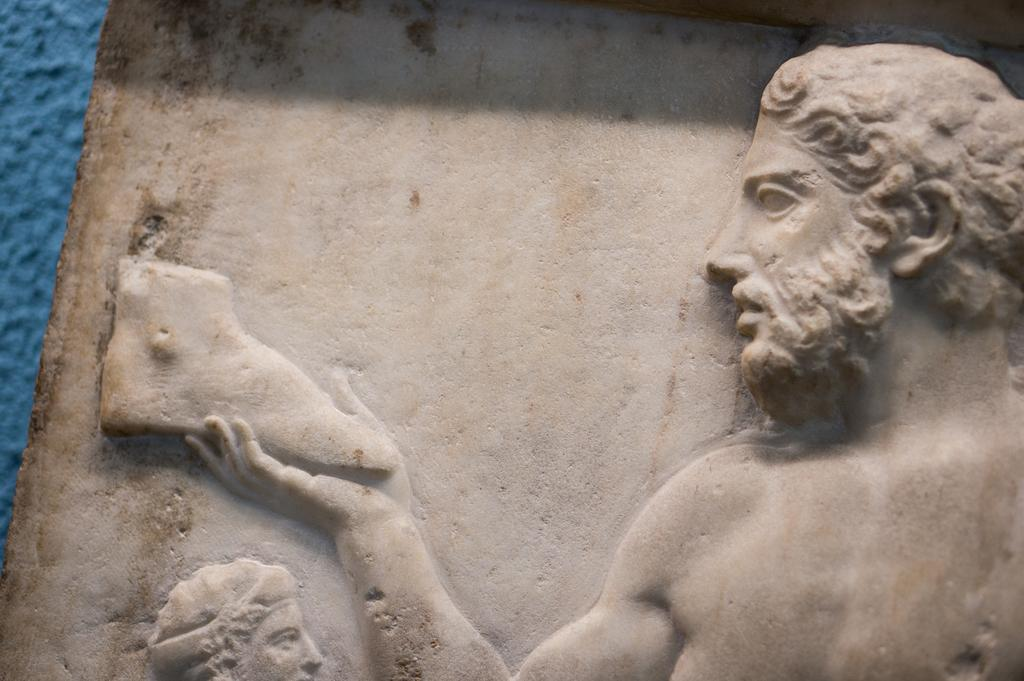What type of objects can be seen in the image? There are sculptures in the image. Where are the sculptures located? The sculptures are on a stone. What type of leather material can be seen on the sculptures in the image? There is no leather material present on the sculptures in the image. How do the sculptures curve in the image? The sculptures do not curve in the image; they are stationary on the stone. 